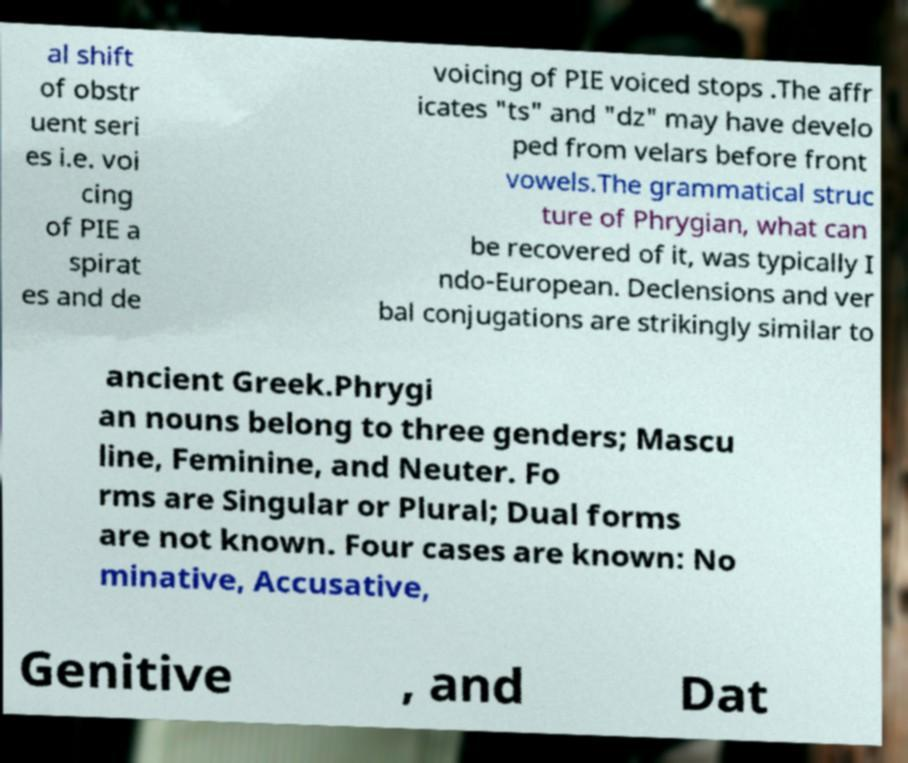What messages or text are displayed in this image? I need them in a readable, typed format. al shift of obstr uent seri es i.e. voi cing of PIE a spirat es and de voicing of PIE voiced stops .The affr icates "ts" and "dz" may have develo ped from velars before front vowels.The grammatical struc ture of Phrygian, what can be recovered of it, was typically I ndo-European. Declensions and ver bal conjugations are strikingly similar to ancient Greek.Phrygi an nouns belong to three genders; Mascu line, Feminine, and Neuter. Fo rms are Singular or Plural; Dual forms are not known. Four cases are known: No minative, Accusative, Genitive , and Dat 